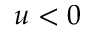Convert formula to latex. <formula><loc_0><loc_0><loc_500><loc_500>u < 0</formula> 